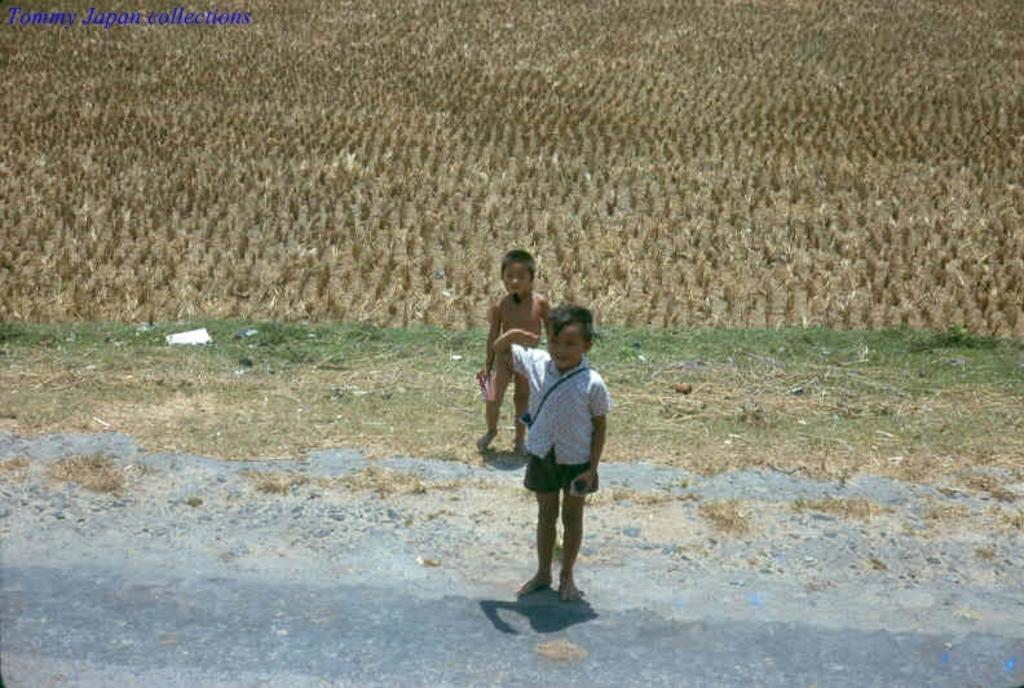What can be seen in the background of the image? There is a dried field area in the background of the image. How many boys are present in the image? There are two boys standing in the image. What is visible at the bottom of the image? There is a road visible at the bottom of the image. What type of digestion can be observed in the image? There is no digestion present in the image; it features a dried field area, two boys, and a road. What type of bait is being used by the boys in the image? There is no bait or fishing activity present in the image. 